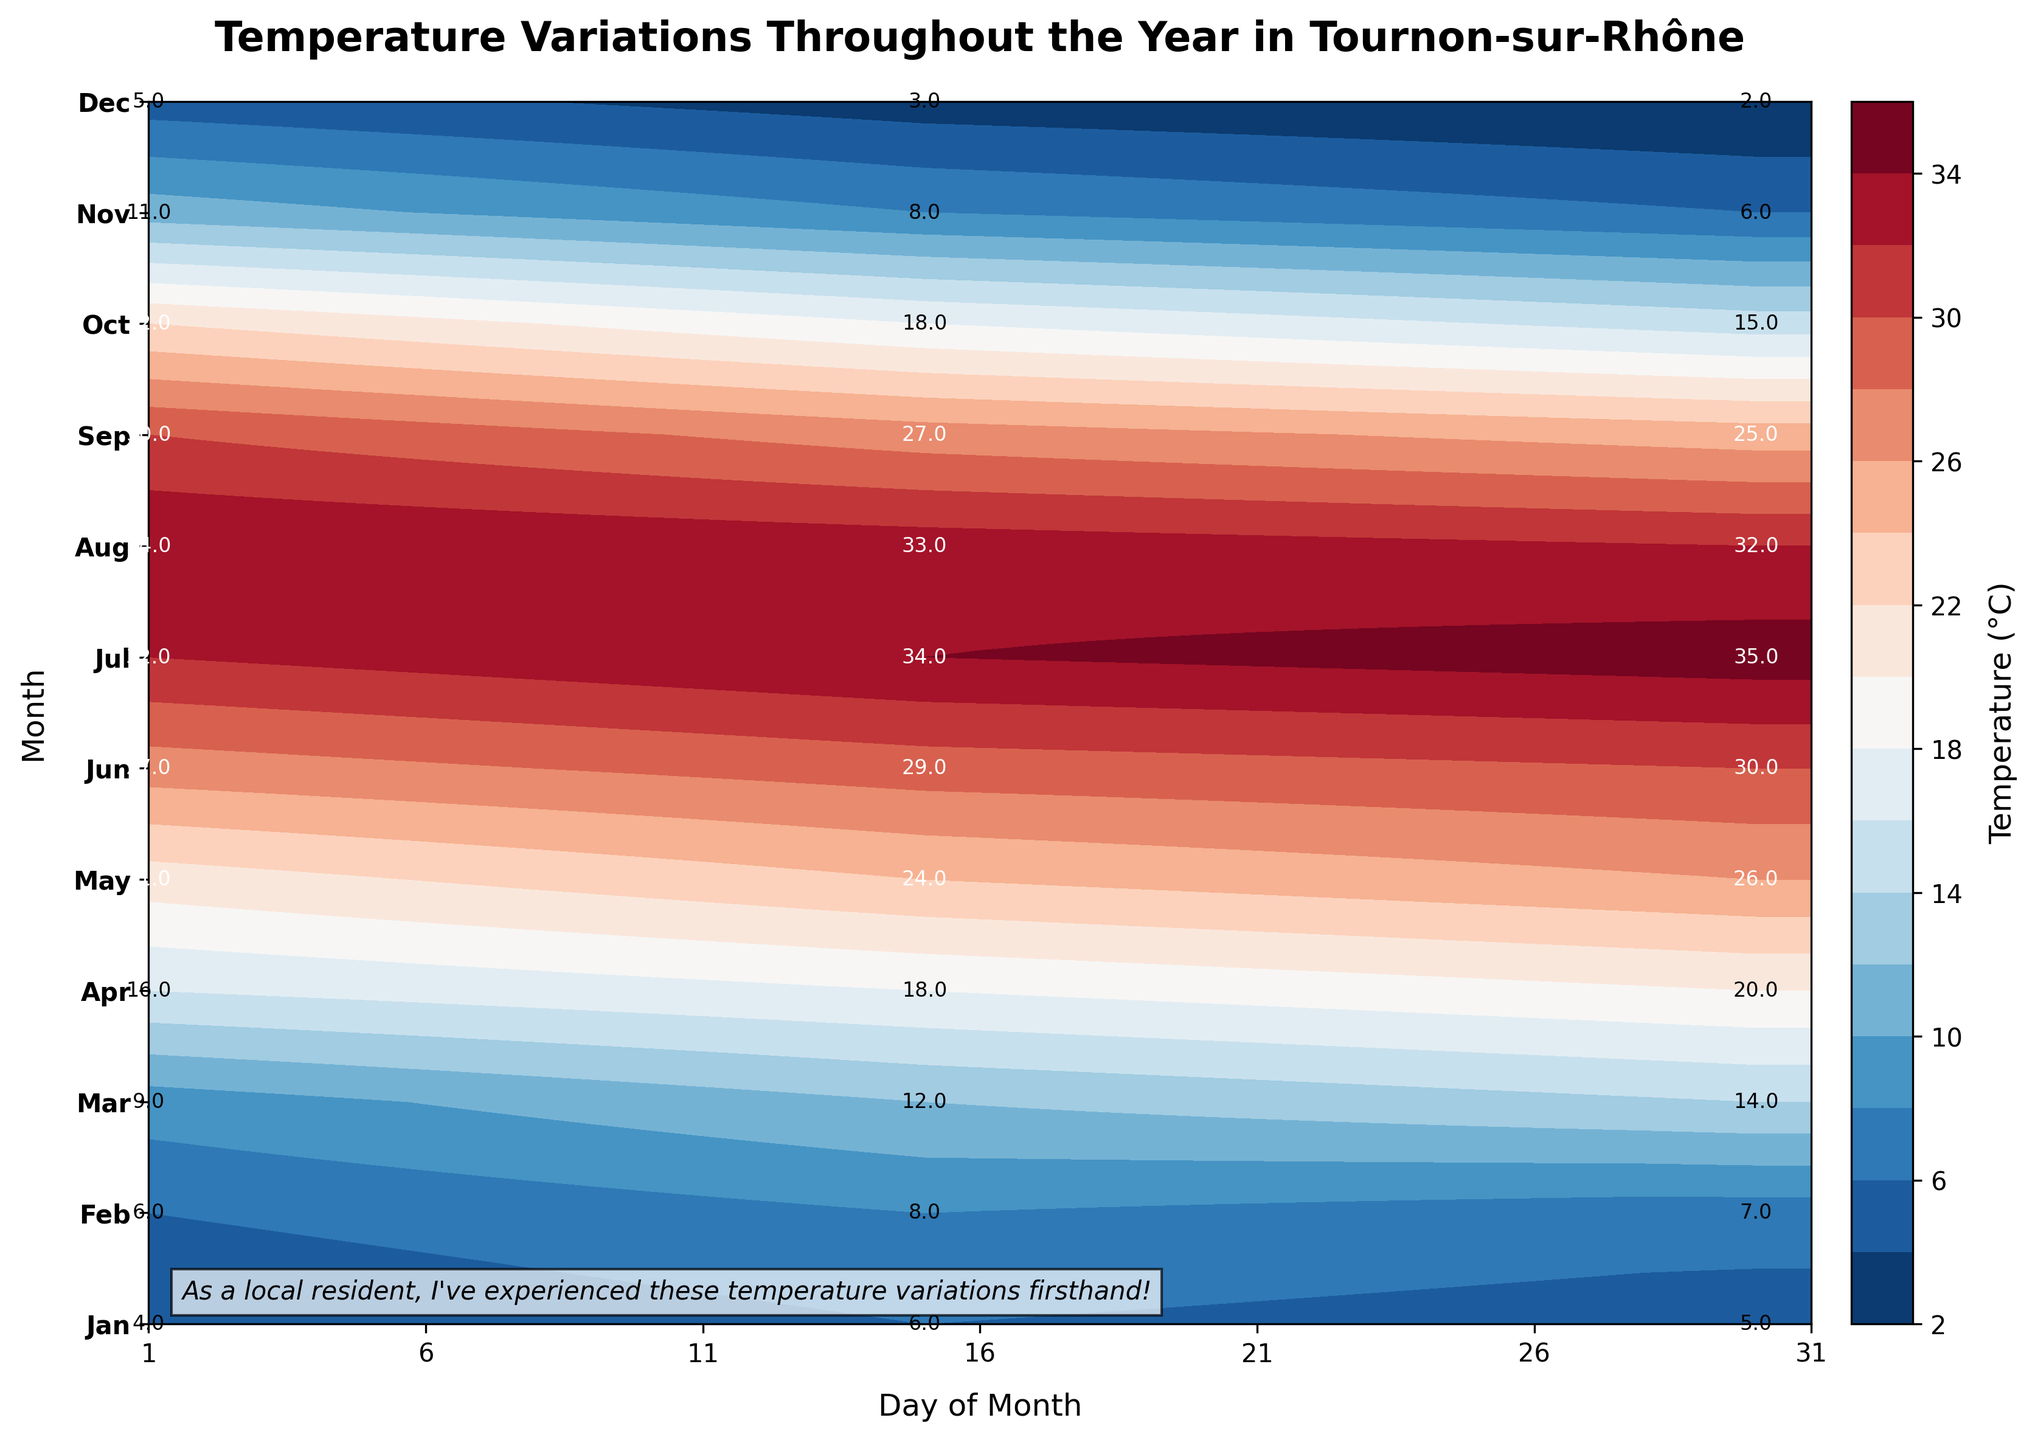What's the title of the plot? The title is displayed at the top of the plot and reads, "Temperature Variations Throughout the Year in Tournon-sur-Rhône."
Answer: Temperature Variations Throughout the Year in Tournon-sur-Rhône Which month has the highest recorded temperature, and what is it? By looking at the contour plot and the annotations, July has the highest recorded temperature, which is 35°C.
Answer: July, 35°C What is the temperature on January 15th? The temperature on January 15th is specified beside the annotation at the January row and the 15th column, which is 6°C.
Answer: 6°C How does the temperature on November 1st compare to the temperature on November 30th? The annotation shows that the temperature on November 1st is 11°C, while on November 30th it is 6°C. By comparison, November 1st is warmer.
Answer: November 1st is warmer What's the average temperature in April? To find the average temperature in April, you take the values on April 1st, April 15th, and April 30th (16°C, 18°C, 20°C), sum them up (16 + 18 + 20 = 54), and then divide by 3.
Answer: 18°C Which month has the highest initial jump in temperature from the 1st to the 15th? By comparing the differences from the 1st to the 15th of each month, March has the highest jump, increasing from 9°C to 12°C, a 3°C difference.
Answer: March Which month experiences the largest temperature drop from the 1st to the 30th? By comparing the temperature drops from the 1st to the 30th of each month, December has the largest drop, going from 5°C to 2°C, a 3°C difference.
Answer: December What is the temperature pattern observed in July? The annotation in July shows temperatures as 32°C on the 1st, 34°C on the 15th, and 35°C on the 30th, indicating a rising pattern throughout the month.
Answer: Rising What is the approximate temperature on May 15th? The temperature on May 15th is labeled next to the corresponding date and month, which is 24°C.
Answer: 24°C 